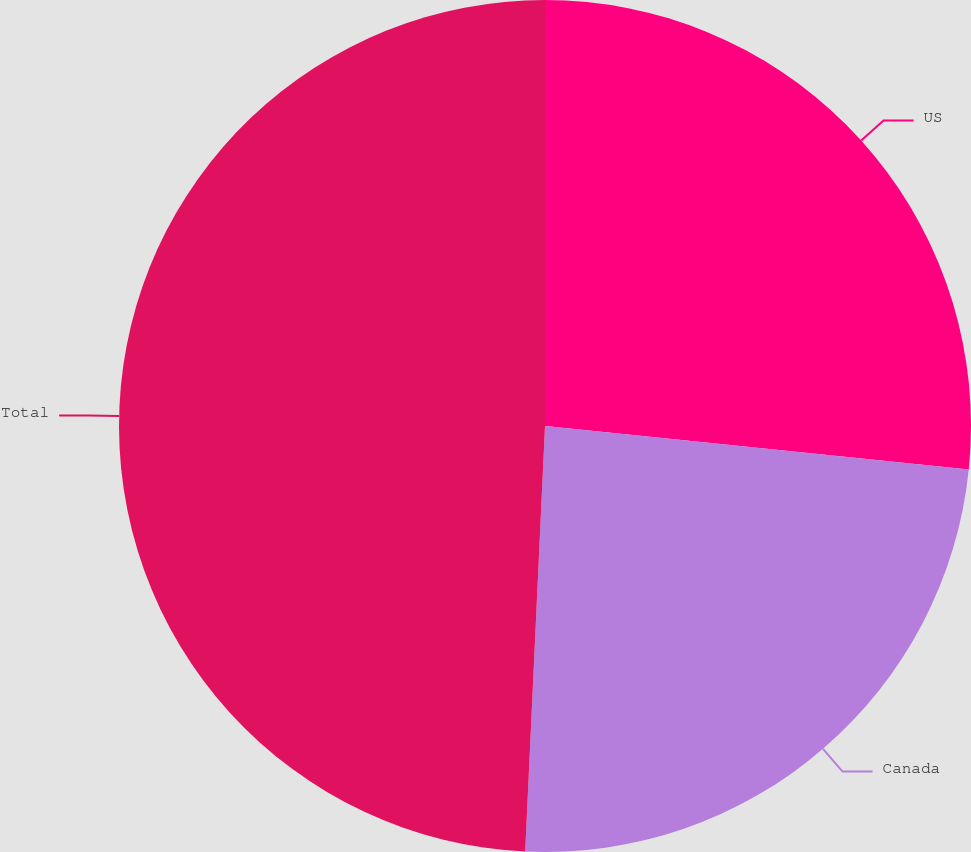<chart> <loc_0><loc_0><loc_500><loc_500><pie_chart><fcel>US<fcel>Canada<fcel>Total<nl><fcel>26.63%<fcel>24.11%<fcel>49.26%<nl></chart> 